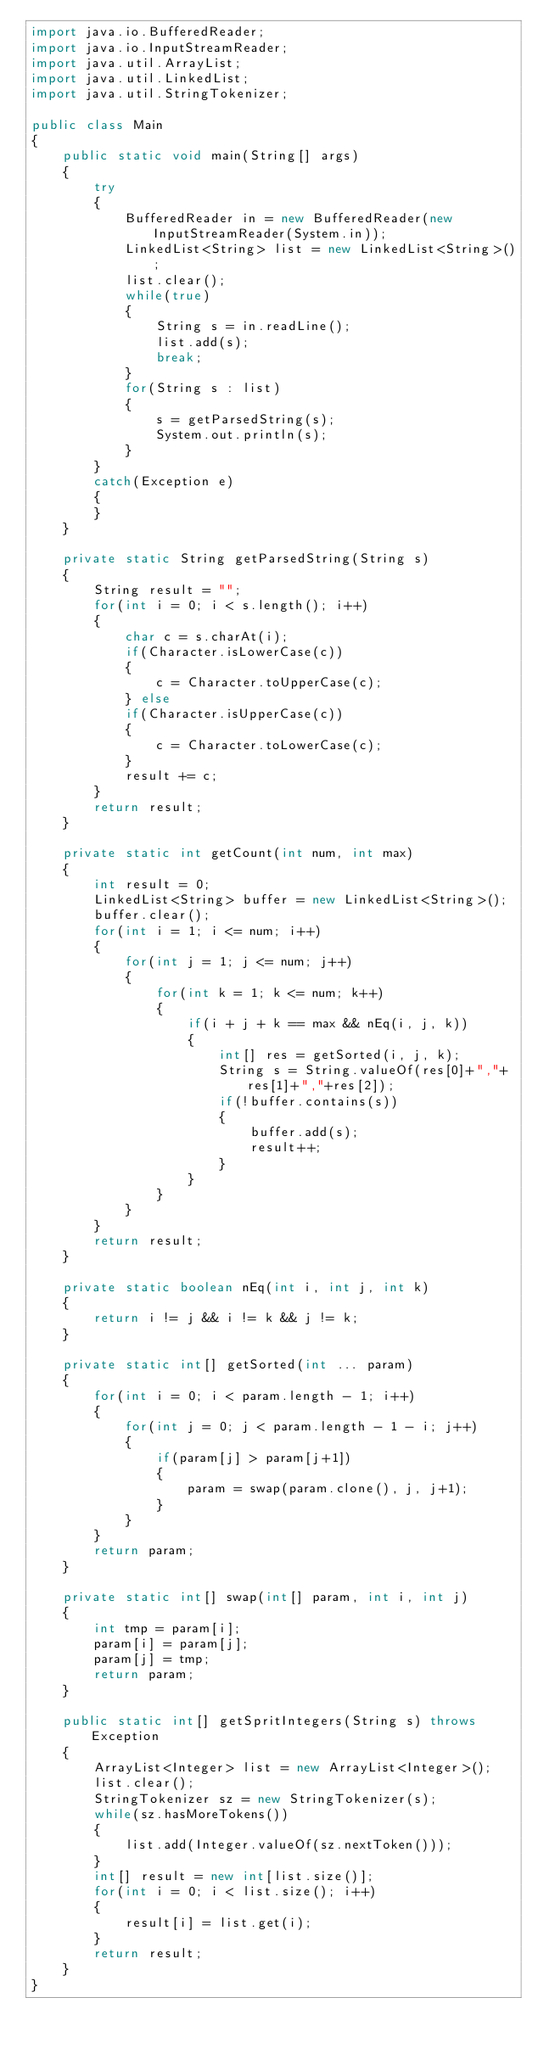<code> <loc_0><loc_0><loc_500><loc_500><_Java_>import java.io.BufferedReader;
import java.io.InputStreamReader;
import java.util.ArrayList;
import java.util.LinkedList;
import java.util.StringTokenizer;

public class Main
{
	public static void main(String[] args)
	{
		try
		{
			BufferedReader in = new BufferedReader(new InputStreamReader(System.in));
			LinkedList<String> list = new LinkedList<String>();
			list.clear();
			while(true)
			{
				String s = in.readLine();
				list.add(s);
				break;
			}
			for(String s : list)
			{
				s = getParsedString(s);
				System.out.println(s);
			}
		}
		catch(Exception e)
		{
		}
	}

	private static String getParsedString(String s)
	{
		String result = "";
		for(int i = 0; i < s.length(); i++)
		{
			char c = s.charAt(i);
			if(Character.isLowerCase(c))
			{
				c = Character.toUpperCase(c);
			} else
			if(Character.isUpperCase(c))
			{
				c = Character.toLowerCase(c);
			}
			result += c;
		}
		return result;
	}

	private static int getCount(int num, int max)
	{
		int result = 0;
		LinkedList<String> buffer = new LinkedList<String>();
		buffer.clear();
		for(int i = 1; i <= num; i++)
		{
			for(int j = 1; j <= num; j++)
			{
				for(int k = 1; k <= num; k++)
				{
					if(i + j + k == max && nEq(i, j, k))
					{
						int[] res = getSorted(i, j, k);
						String s = String.valueOf(res[0]+","+res[1]+","+res[2]);
						if(!buffer.contains(s))
						{
							buffer.add(s);
							result++;
						}
					}
				}
			}
		}
		return result;
	}

	private static boolean nEq(int i, int j, int k)
	{
		return i != j && i != k && j != k;
	}

	private static int[] getSorted(int ... param)
	{
		for(int i = 0; i < param.length - 1; i++)
		{
			for(int j = 0; j < param.length - 1 - i; j++)
			{
				if(param[j] > param[j+1])
				{
					param = swap(param.clone(), j, j+1);
				}
			}
		}
		return param;
	}

	private static int[] swap(int[] param, int i, int j)
	{
		int tmp = param[i];
		param[i] = param[j];
		param[j] = tmp;
		return param;
	}

	public static int[] getSpritIntegers(String s) throws Exception
	{
		ArrayList<Integer> list = new ArrayList<Integer>();
		list.clear();
		StringTokenizer sz = new StringTokenizer(s);
		while(sz.hasMoreTokens())
		{
			list.add(Integer.valueOf(sz.nextToken()));
		}
		int[] result = new int[list.size()];
		for(int i = 0; i < list.size(); i++)
		{
			result[i] = list.get(i);
		}
		return result;
	}
}</code> 